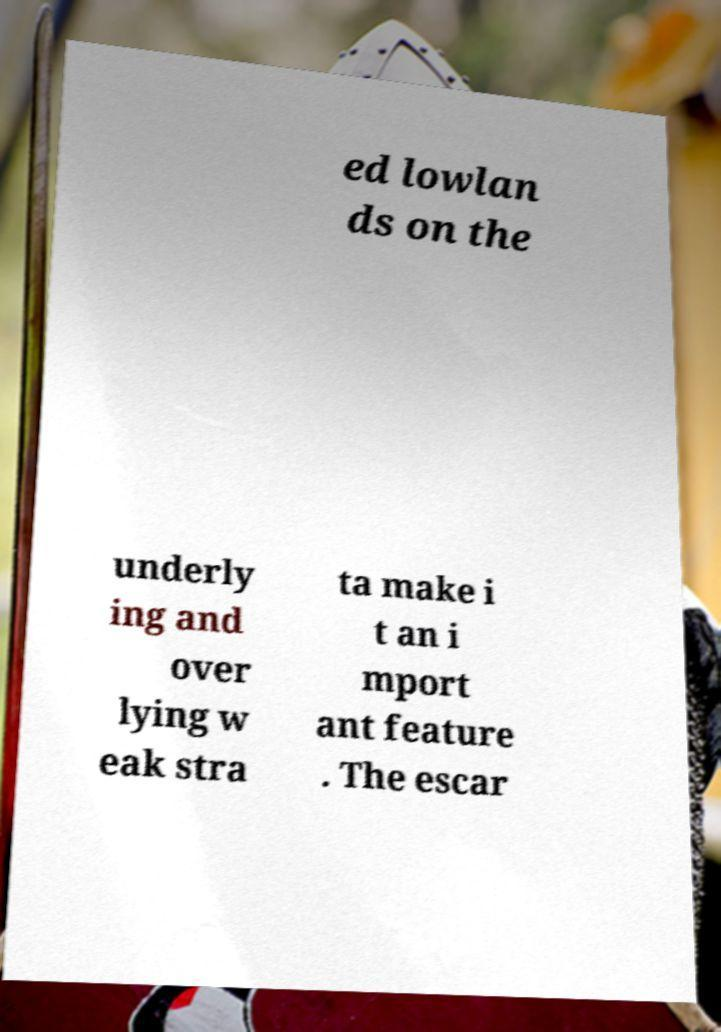Please identify and transcribe the text found in this image. ed lowlan ds on the underly ing and over lying w eak stra ta make i t an i mport ant feature . The escar 